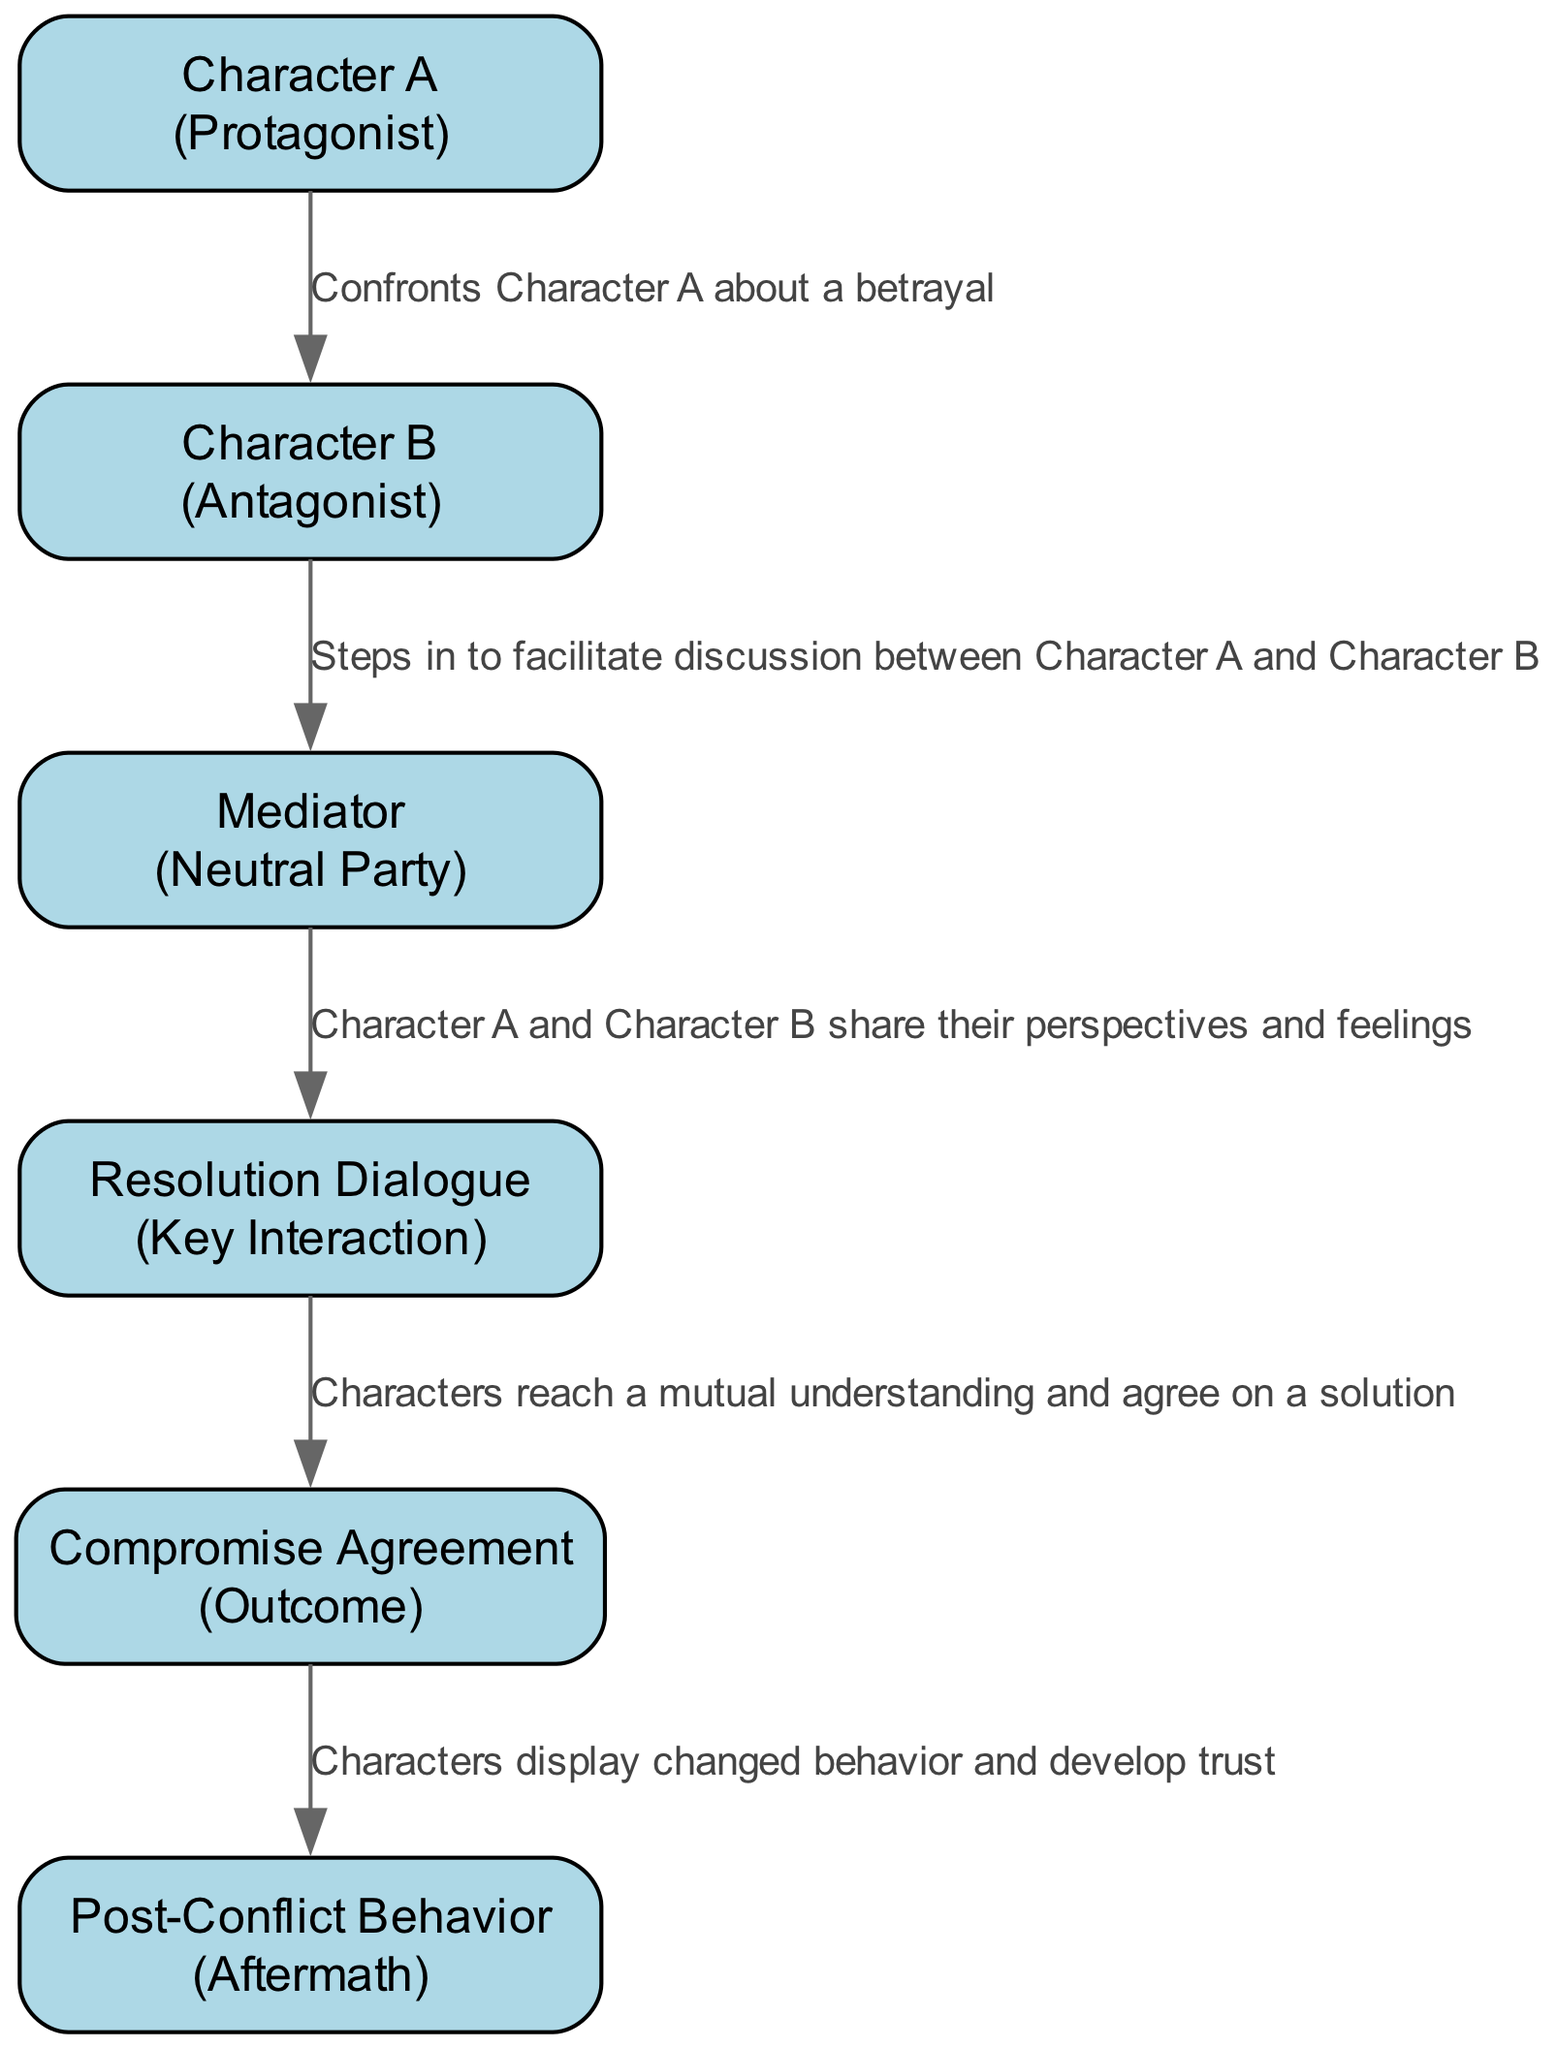What is the first action in the sequence? The first action in the sequence is described as "Experiences a sudden conflict with Character B," which is the action associated with Character A.
Answer: Experiences a sudden conflict with Character B Who is the mediator in the conflict resolution? The mediator in the conflict resolution is identified as the "Mediator," who takes on the role of a neutral party to facilitate discussion.
Answer: Mediator What is the last action taken in the sequence? The last action taken in the sequence is described as "Characters display changed behavior and develop trust," marking the aftermath of the conflict resolution process.
Answer: Characters display changed behavior and develop trust How many characters are involved in the sequence? The sequence includes three distinct characters: Character A, Character B, and the Mediator. Adding the outcome and dialogue, there are five individual elements, but only three of them are characters.
Answer: 3 What action follows the resolution dialogue? The action that follows the resolution dialogue is "Characters reach a mutual understanding and agree on a solution," which signifies the compromise agreement between the involved characters.
Answer: Characters reach a mutual understanding and agree on a solution Which character confronts Character A? Character B is the one who confronts Character A about the betrayal, marking the initial conflict in the sequence.
Answer: Character B How does the sequence progress after the sudden conflict? After the sudden conflict, the sequence progresses through Character B confronting Character A, followed by the involvement of the Mediator to facilitate a discussion, leading to resolution dialogue, a compromise agreement, and ultimately, changed behavior.
Answer: Confronts the protagonist, Mediator steps in, resolution dialogue, compromise agreement, changed behavior What role does the "Resolution Dialogue" play in the sequence? The Resolution Dialogue serves as the key interaction where both characters share their perspectives and feelings, a vital component in the conflict resolution process.
Answer: Key Interaction What type of diagram represents the flow of conflict resolution? The flow of conflict resolution is represented by a Sequence diagram, which specifically illustrates the interactions and actions of characters over time.
Answer: Sequence diagram 